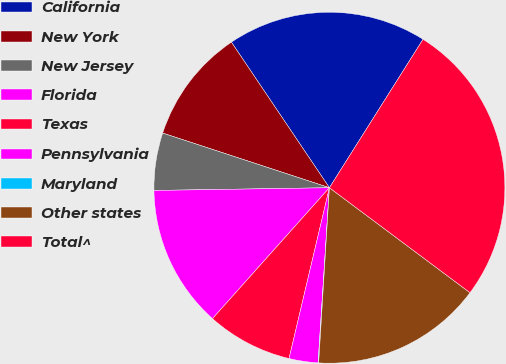Convert chart to OTSL. <chart><loc_0><loc_0><loc_500><loc_500><pie_chart><fcel>California<fcel>New York<fcel>New Jersey<fcel>Florida<fcel>Texas<fcel>Pennsylvania<fcel>Maryland<fcel>Other states<fcel>Total^<nl><fcel>18.39%<fcel>10.53%<fcel>5.29%<fcel>13.15%<fcel>7.91%<fcel>2.67%<fcel>0.05%<fcel>15.77%<fcel>26.25%<nl></chart> 